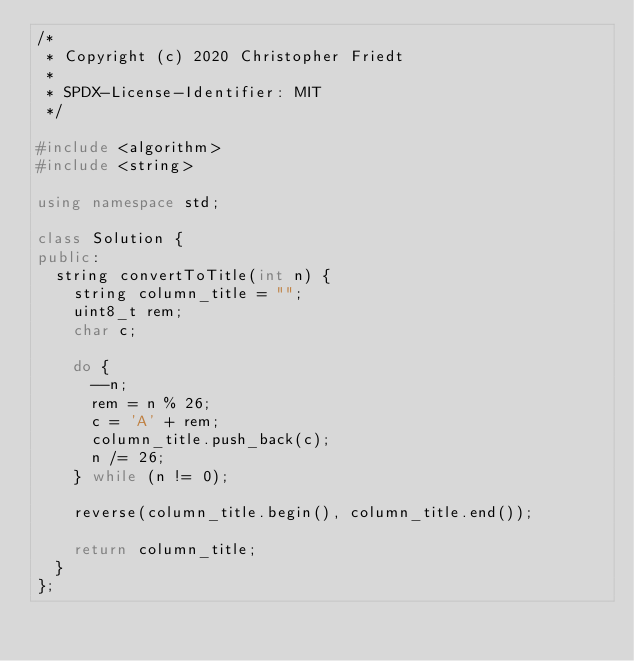<code> <loc_0><loc_0><loc_500><loc_500><_C++_>/*
 * Copyright (c) 2020 Christopher Friedt
 *
 * SPDX-License-Identifier: MIT
 */

#include <algorithm>
#include <string>

using namespace std;

class Solution {
public:
  string convertToTitle(int n) {
    string column_title = "";
    uint8_t rem;
    char c;

    do {
      --n;
      rem = n % 26;
      c = 'A' + rem;
      column_title.push_back(c);
      n /= 26;
    } while (n != 0);

    reverse(column_title.begin(), column_title.end());

    return column_title;
  }
};
</code> 